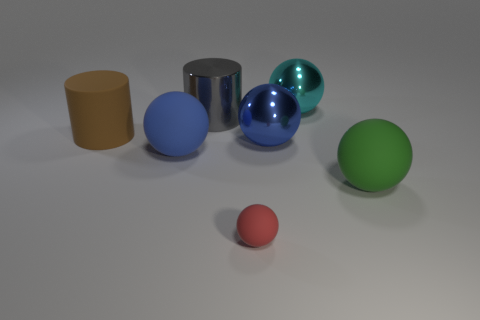How many big blue metal balls are behind the big ball on the left side of the tiny rubber object?
Give a very brief answer. 1. What material is the cylinder that is the same size as the brown rubber thing?
Your response must be concise. Metal. There is a large matte object behind the blue rubber thing; is its shape the same as the tiny red matte thing?
Your answer should be very brief. No. Are there more metallic spheres left of the green ball than cyan things that are in front of the large brown thing?
Give a very brief answer. Yes. What number of cyan spheres are the same material as the cyan thing?
Provide a short and direct response. 0. Do the blue matte thing and the red matte object have the same size?
Offer a terse response. No. The shiny cylinder is what color?
Provide a succinct answer. Gray. What number of things are gray objects or big brown matte objects?
Give a very brief answer. 2. Is there a brown matte thing of the same shape as the large gray metallic object?
Offer a very short reply. Yes. There is a blue rubber object on the left side of the shiny sphere behind the large rubber cylinder; what shape is it?
Give a very brief answer. Sphere. 